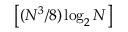<formula> <loc_0><loc_0><loc_500><loc_500>\left [ ( N ^ { 3 } / 8 ) \log _ { 2 } N \right ]</formula> 